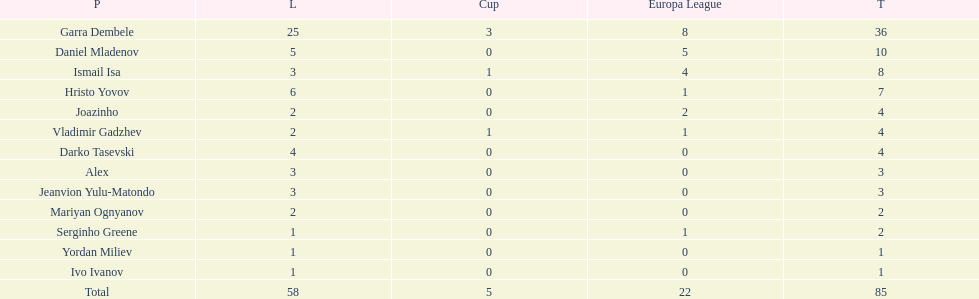What is the difference between vladimir gadzhev and yordan miliev's scores? 3. 